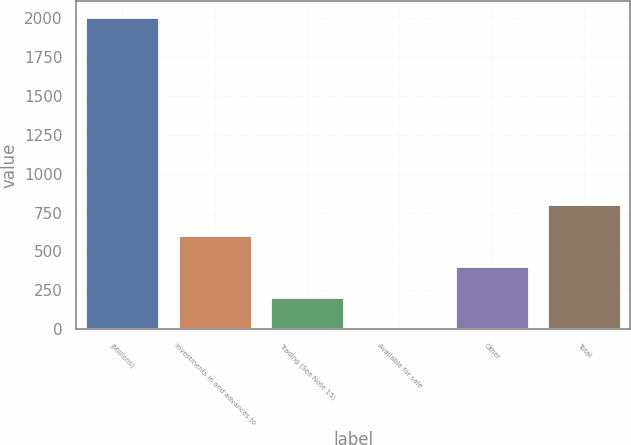Convert chart. <chart><loc_0><loc_0><loc_500><loc_500><bar_chart><fcel>(Millions)<fcel>Investments in and advances to<fcel>Trading (See Note 15)<fcel>Available for sale<fcel>Other<fcel>Total<nl><fcel>2010<fcel>607.2<fcel>206.4<fcel>6<fcel>406.8<fcel>807.6<nl></chart> 